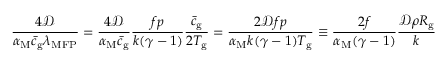Convert formula to latex. <formula><loc_0><loc_0><loc_500><loc_500>\frac { 4 \mathcal { D } } { \alpha _ { M } \bar { c } _ { g } \lambda _ { M F P } } = \frac { 4 \mathcal { D } } { \alpha _ { M } \bar { c } _ { g } } \frac { f p } { k ( \gamma - 1 ) } \frac { \bar { c } _ { g } } { 2 T _ { g } } = \frac { 2 \mathcal { D } f p } { \alpha _ { M } k ( \gamma - 1 ) T _ { g } } \equiv \frac { 2 f } { \alpha _ { M } ( \gamma - 1 ) } \frac { \mathcal { D } \rho R _ { g } } { k }</formula> 